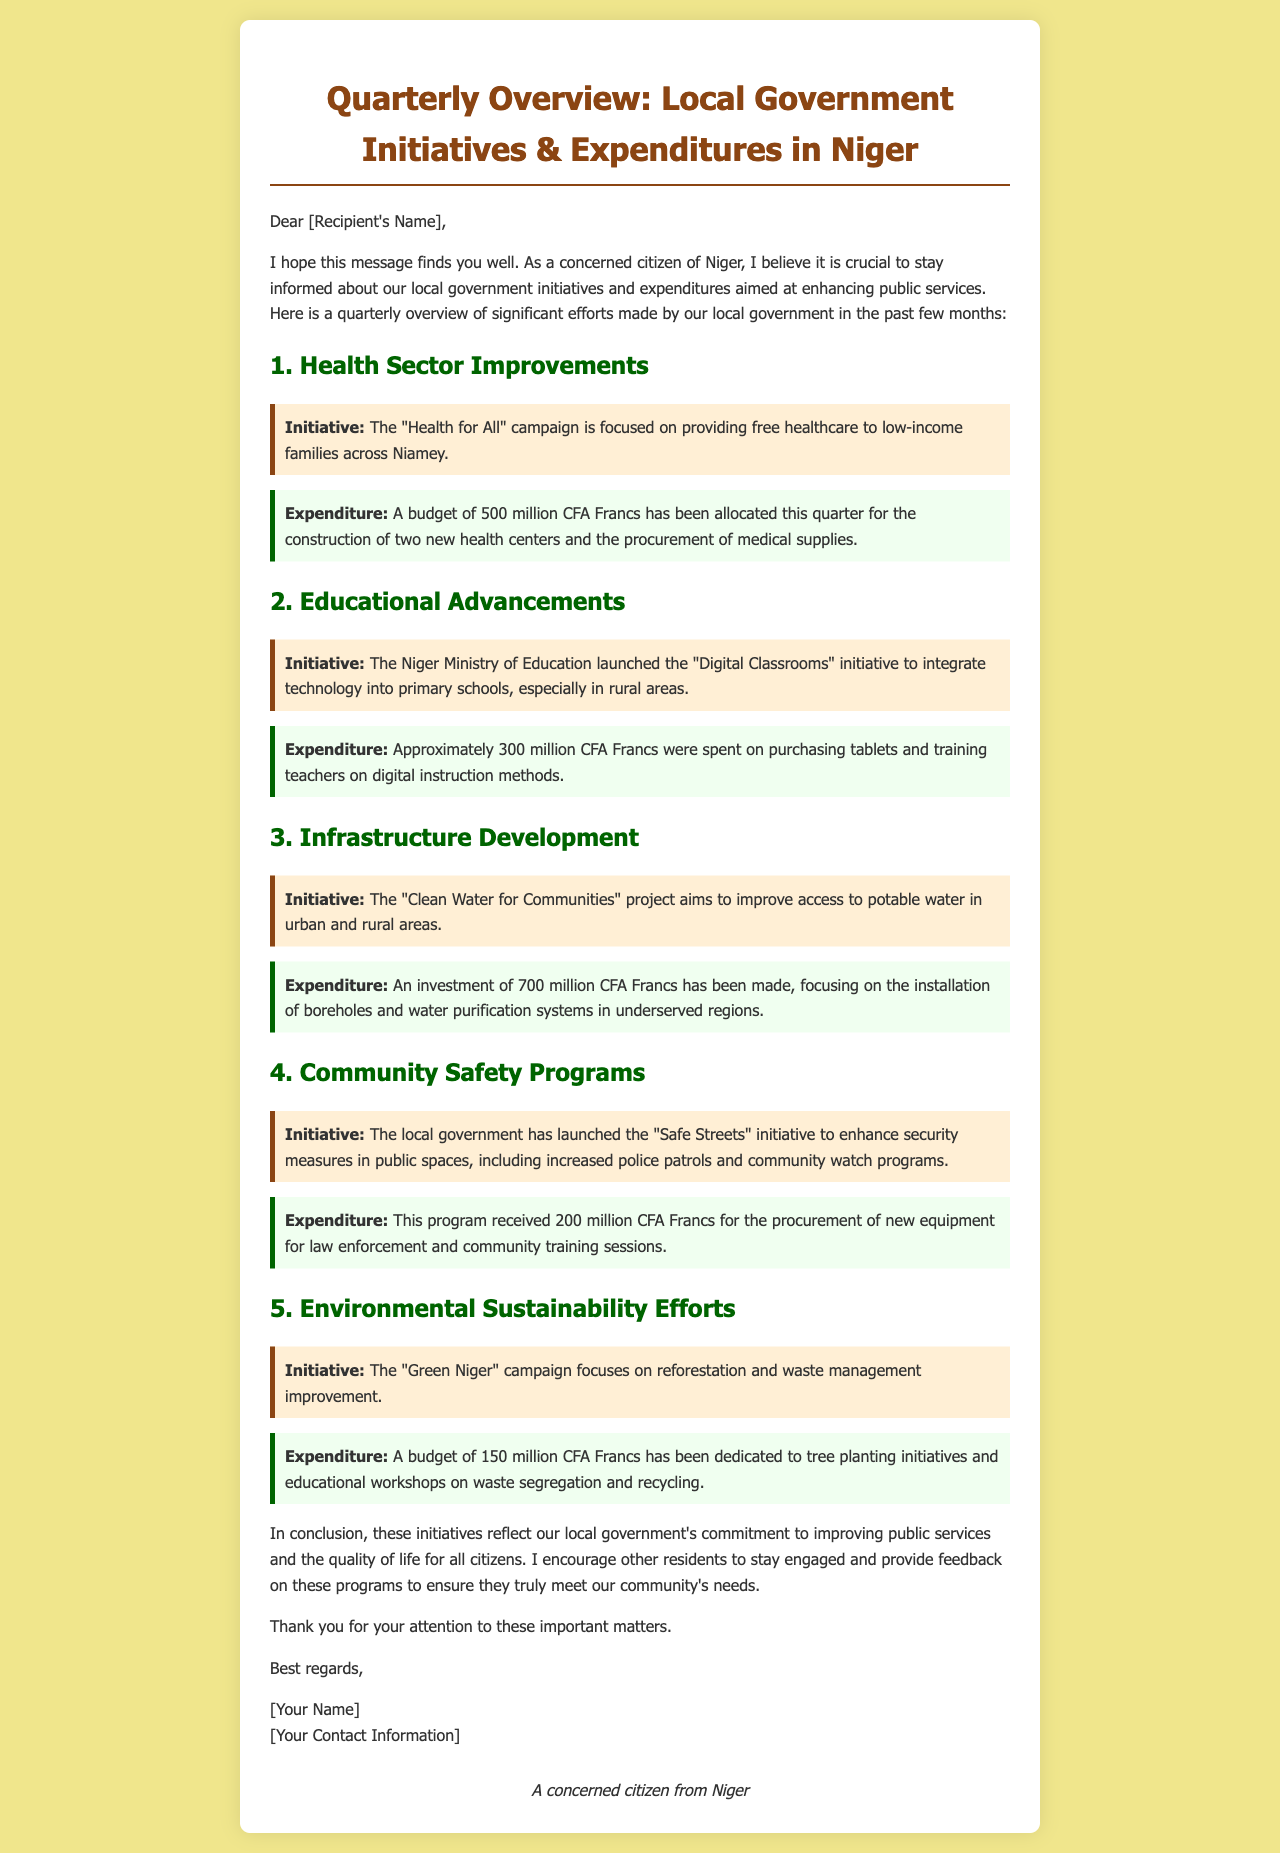what is the total budget allocated for health sector improvements this quarter? The total budget allocated for health sector improvements this quarter is stated as 500 million CFA Francs in the document.
Answer: 500 million CFA Francs what is the main initiative for educational advancements? The main initiative for educational advancements is "Digital Classrooms" which aims to integrate technology into primary schools.
Answer: Digital Classrooms how much was spent on community safety programs? The amount spent on community safety programs is indicated as 200 million CFA Francs in the document.
Answer: 200 million CFA Francs what initiative aims to improve access to potable water? The initiative aimed at improving access to potable water is called "Clean Water for Communities."
Answer: Clean Water for Communities what is the focus of the "Green Niger" campaign? The focus of the "Green Niger" campaign includes reforestation and waste management improvement.
Answer: Reforestation and waste management improvement how many new health centers are being constructed this quarter? Two new health centers are being constructed this quarter as part of the health sector improvements.
Answer: Two what was the expenditure for the "Digital Classrooms" initiative? The expenditure for the "Digital Classrooms" initiative is approximately 300 million CFA Francs.
Answer: 300 million CFA Francs what does the "Safe Streets" initiative aim to enhance? The "Safe Streets" initiative aims to enhance security measures in public spaces.
Answer: Security measures in public spaces what is the amount allocated for the "Green Niger" campaign? The amount allocated for the "Green Niger" campaign is 150 million CFA Francs according to the document.
Answer: 150 million CFA Francs 